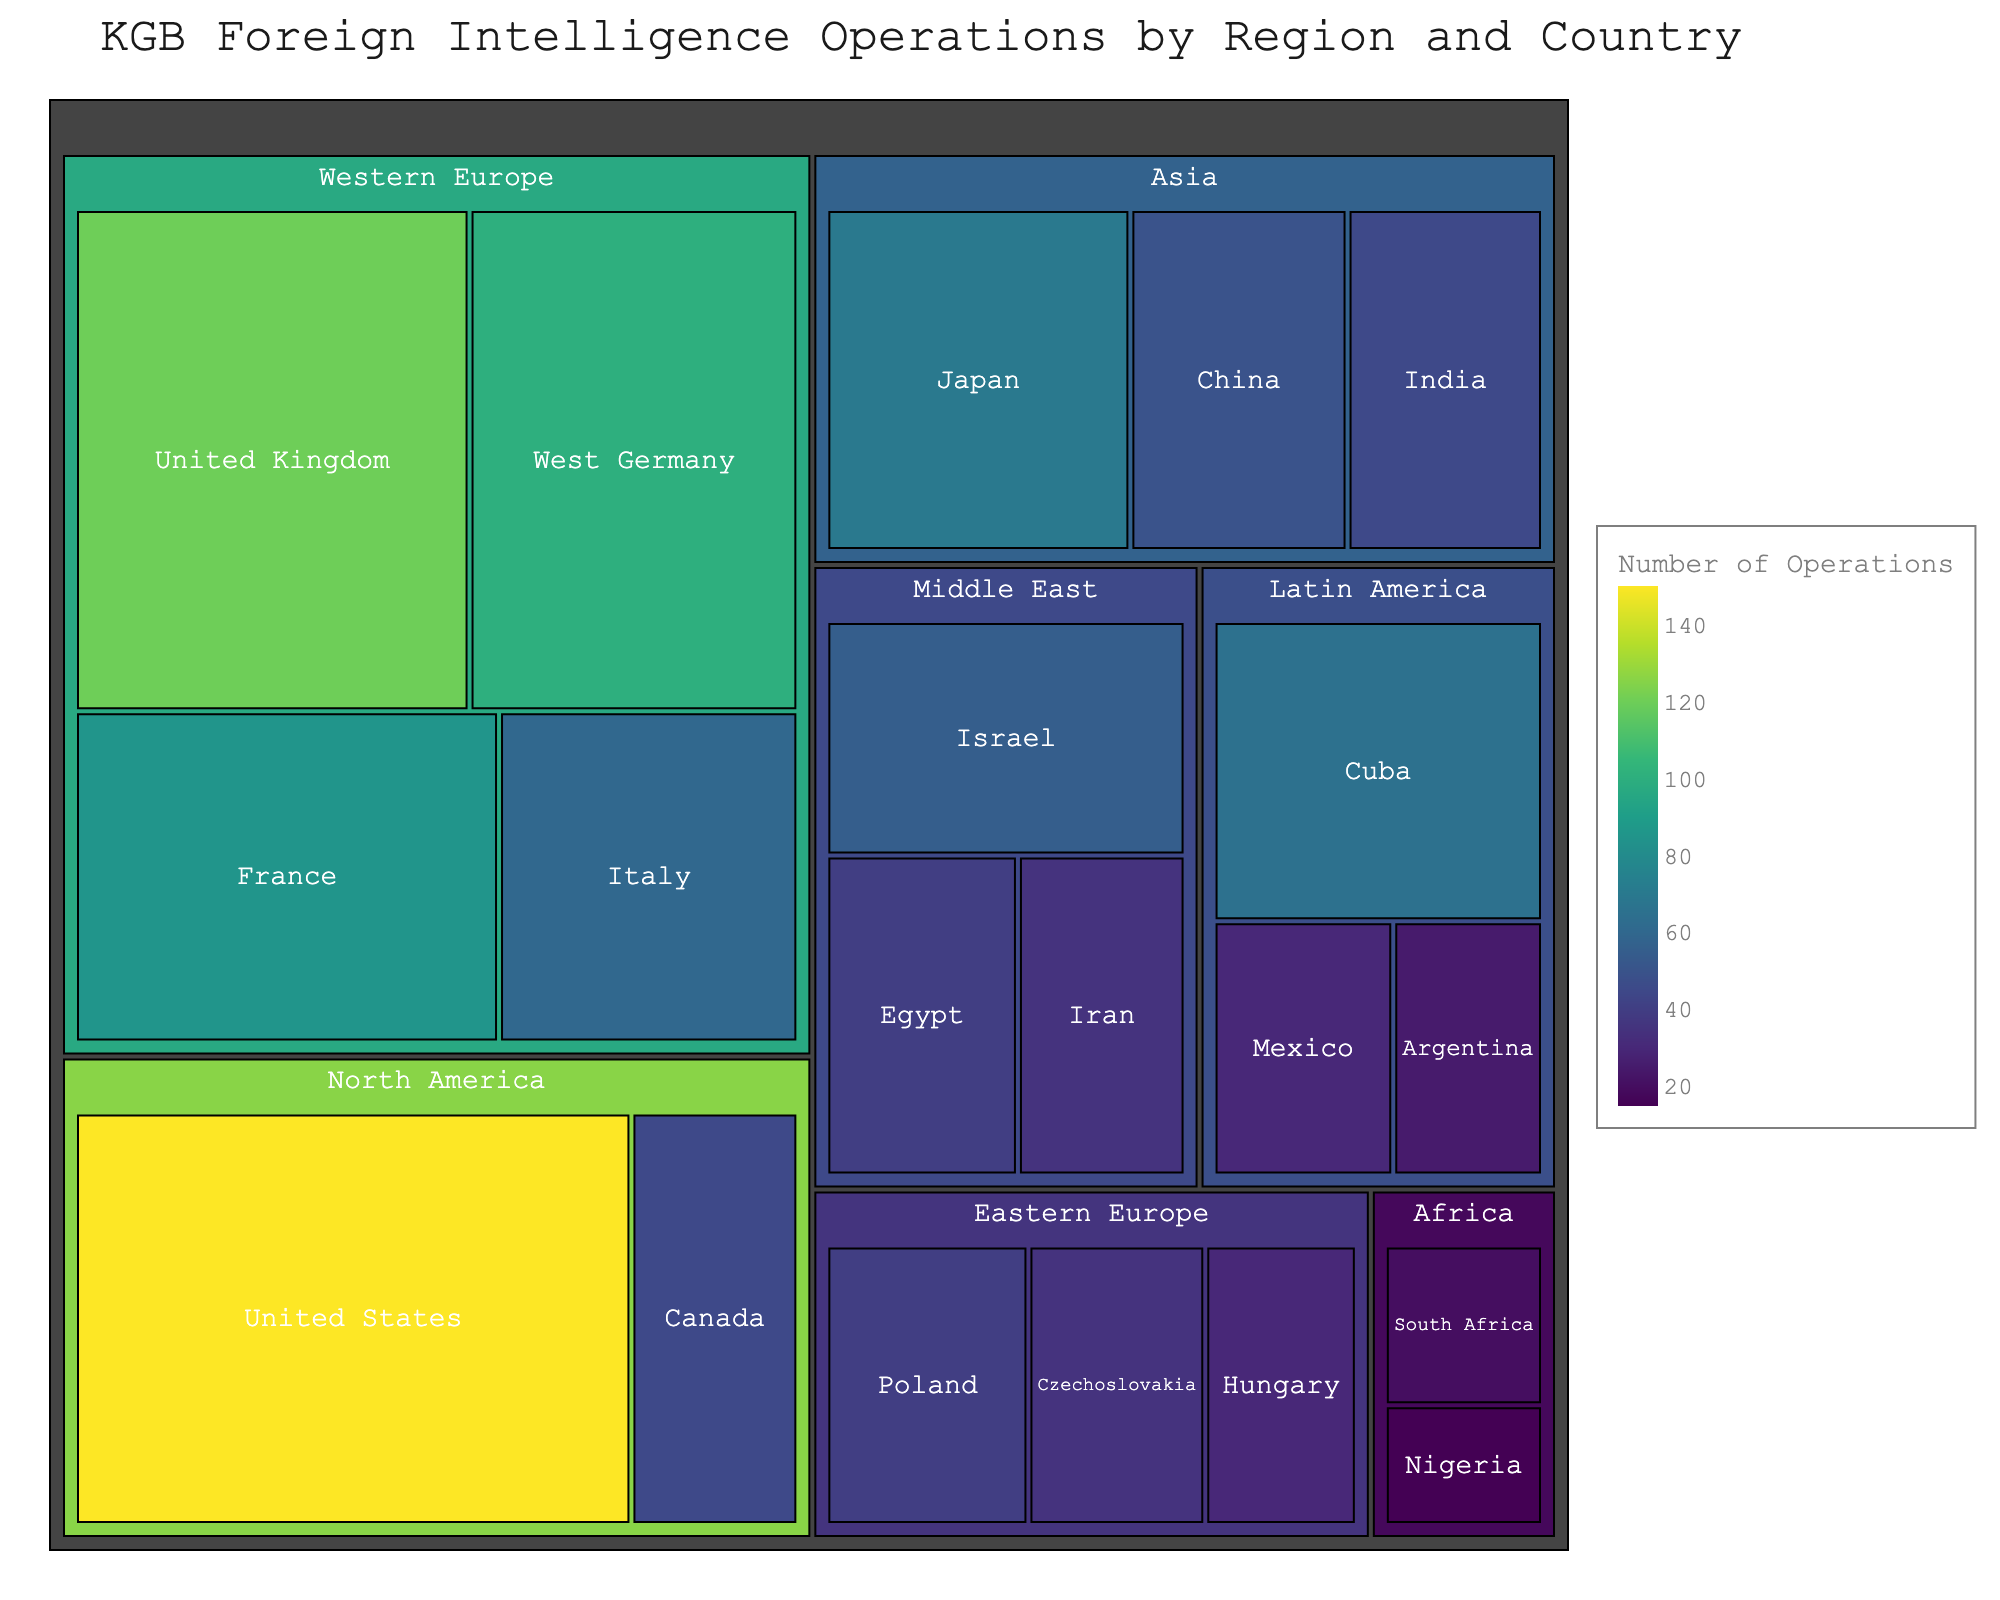What's the title of the plot? The title of the plot is displayed prominently at the top and provides a summary of what the plot is about.
Answer: KGB Foreign Intelligence Operations by Region and Country Which country had the highest number of KGB operations? The size of each tile and the color gradient signify the number of operations, with larger and darker tiles indicating more operations. The largest, darkest tile is the United States.
Answer: United States What is the total number of operations conducted in North America? The North America region consists of the United States and Canada. Add the number of operations in each: 150 (United States) + 45 (Canada) = 195.
Answer: 195 How does the number of operations in France compare to that in West Germany? Compare the sizes and colors of the tiles for France and West Germany. The France tile shows 85 operations, and the West Germany tile shows 100 operations, indicating more operations in West Germany.
Answer: West Germany has more operations than France What is the average number of operations per country in Western Europe? Western Europe includes the United Kingdom, West Germany, France, and Italy. Sum these operations: 120 + 100 + 85 + 60 = 365. There are 4 countries, so the average is 365 / 4 = 91.25.
Answer: 91.25 Which regions have more than 100 operations in total? Sum the number of operations for each region and compare against 100. North America: 195, Western Europe: 365, Eastern Europe: 105, Middle East: 130, Asia: 165, Latin America: 120, Africa: 35. Regions over 100 are North America, Western Europe, Middle East, Asia, and Latin America.
Answer: North America, Western Europe, Middle East, Asia, Latin America How many more operations were conducted in Japan than in India? Compare the operations in Japan (70) and India (45). Subtract India's operations from Japan's: 70 - 45 = 25.
Answer: 25 What is the smallest number of operations conducted in any country in Africa? Africa includes South Africa (20) and Nigeria (15). The smallest value between them is Nigeria with 15 operations.
Answer: 15 What is the total number of KGB operations illustrated in the plot? Sum the number of operations across all countries: (150+45+120+100+85+60+40+35+30+55+40+35+70+50+45+65+30+25+20+15) = 1,115
Answer: 1,115 Which country in the Middle East had the highest number of KGB operations? Compare the tiles for Israel (55), Egypt (40), and Iran (35). Israel has the highest number of operations.
Answer: Israel 